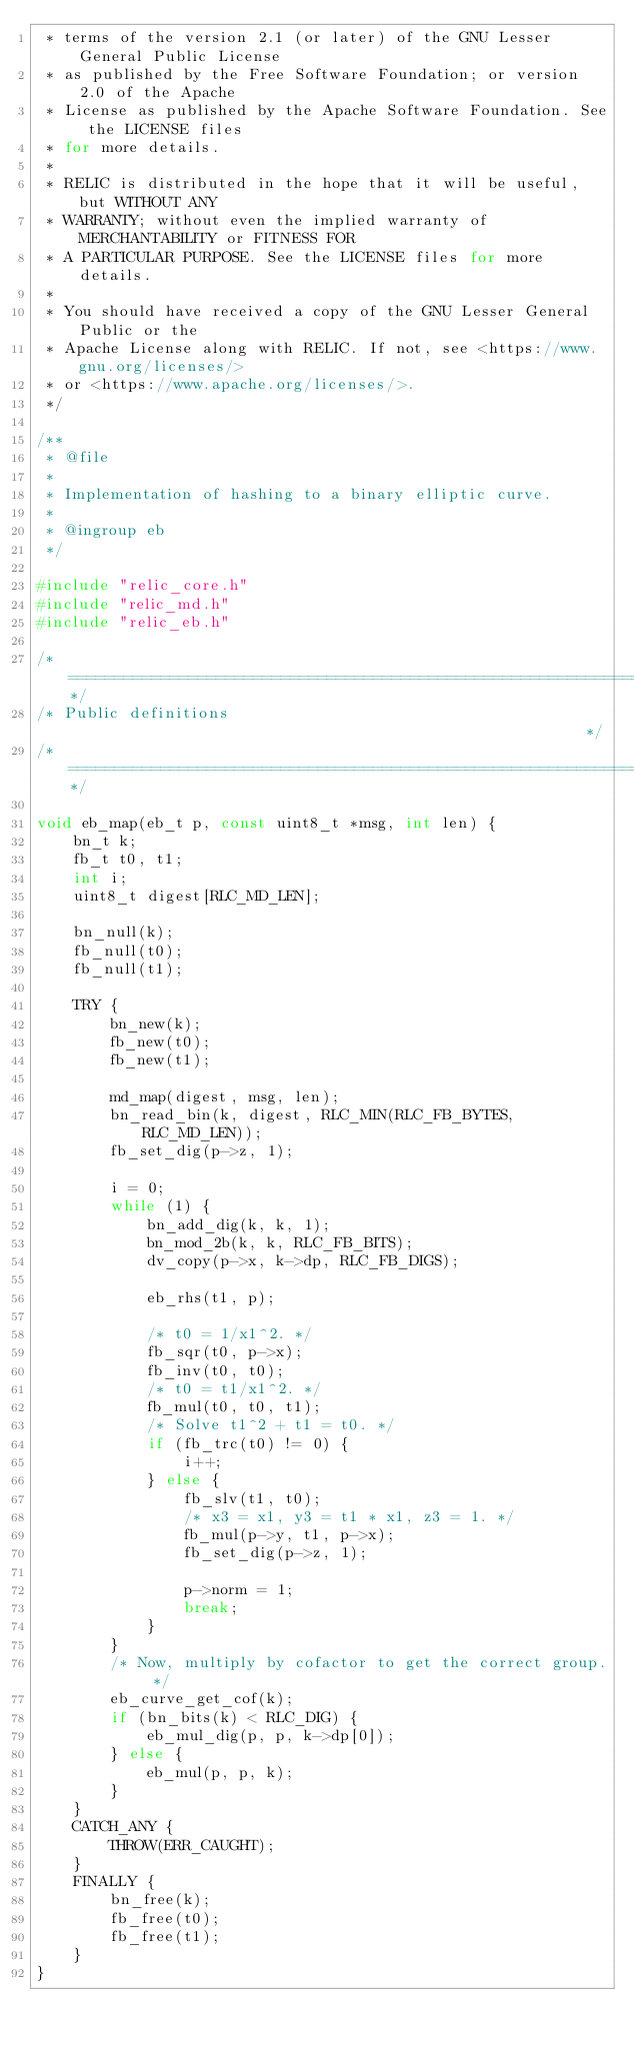<code> <loc_0><loc_0><loc_500><loc_500><_C_> * terms of the version 2.1 (or later) of the GNU Lesser General Public License
 * as published by the Free Software Foundation; or version 2.0 of the Apache
 * License as published by the Apache Software Foundation. See the LICENSE files
 * for more details.
 *
 * RELIC is distributed in the hope that it will be useful, but WITHOUT ANY
 * WARRANTY; without even the implied warranty of MERCHANTABILITY or FITNESS FOR
 * A PARTICULAR PURPOSE. See the LICENSE files for more details.
 *
 * You should have received a copy of the GNU Lesser General Public or the
 * Apache License along with RELIC. If not, see <https://www.gnu.org/licenses/>
 * or <https://www.apache.org/licenses/>.
 */

/**
 * @file
 *
 * Implementation of hashing to a binary elliptic curve.
 *
 * @ingroup eb
 */

#include "relic_core.h"
#include "relic_md.h"
#include "relic_eb.h"

/*============================================================================*/
/* Public definitions                                                         */
/*============================================================================*/

void eb_map(eb_t p, const uint8_t *msg, int len) {
	bn_t k;
	fb_t t0, t1;
	int i;
	uint8_t digest[RLC_MD_LEN];

	bn_null(k);
	fb_null(t0);
	fb_null(t1);

	TRY {
		bn_new(k);
		fb_new(t0);
		fb_new(t1);

		md_map(digest, msg, len);
		bn_read_bin(k, digest, RLC_MIN(RLC_FB_BYTES, RLC_MD_LEN));
		fb_set_dig(p->z, 1);

		i = 0;
		while (1) {
			bn_add_dig(k, k, 1);
			bn_mod_2b(k, k, RLC_FB_BITS);
			dv_copy(p->x, k->dp, RLC_FB_DIGS);

			eb_rhs(t1, p);

			/* t0 = 1/x1^2. */
			fb_sqr(t0, p->x);
			fb_inv(t0, t0);
			/* t0 = t1/x1^2. */
			fb_mul(t0, t0, t1);
			/* Solve t1^2 + t1 = t0. */
			if (fb_trc(t0) != 0) {
				i++;
			} else {
				fb_slv(t1, t0);
				/* x3 = x1, y3 = t1 * x1, z3 = 1. */
				fb_mul(p->y, t1, p->x);
				fb_set_dig(p->z, 1);

				p->norm = 1;
				break;
			}
		}
		/* Now, multiply by cofactor to get the correct group. */
		eb_curve_get_cof(k);
		if (bn_bits(k) < RLC_DIG) {
			eb_mul_dig(p, p, k->dp[0]);
		} else {
			eb_mul(p, p, k);
		}
	}
	CATCH_ANY {
		THROW(ERR_CAUGHT);
	}
	FINALLY {
		bn_free(k);
		fb_free(t0);
		fb_free(t1);
	}
}
</code> 